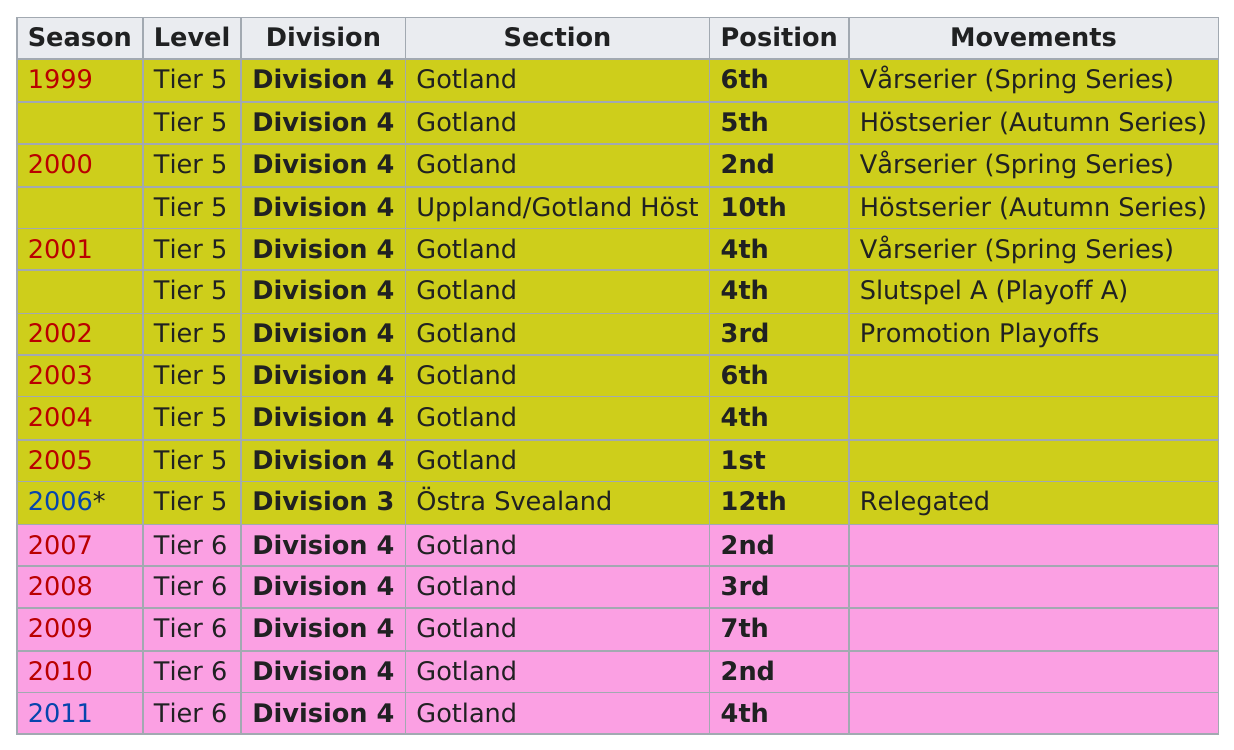Give some essential details in this illustration. In 1999, there was a 6th position season. Four years later, there was another 6th position season. The team's last position that they achieved was fourth. For the past 12 years, they have been playing. The team was previously in Tier 5 in 2007. IFK finished in at least fifth place in how many years? 11 years. 